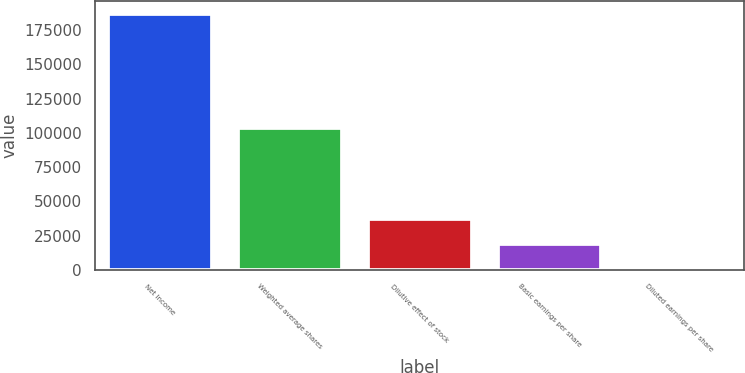<chart> <loc_0><loc_0><loc_500><loc_500><bar_chart><fcel>Net Income<fcel>Weighted average shares<fcel>Dilutive effect of stock<fcel>Basic earnings per share<fcel>Diluted earnings per share<nl><fcel>186715<fcel>103537<fcel>37344.8<fcel>18673.5<fcel>2.19<nl></chart> 